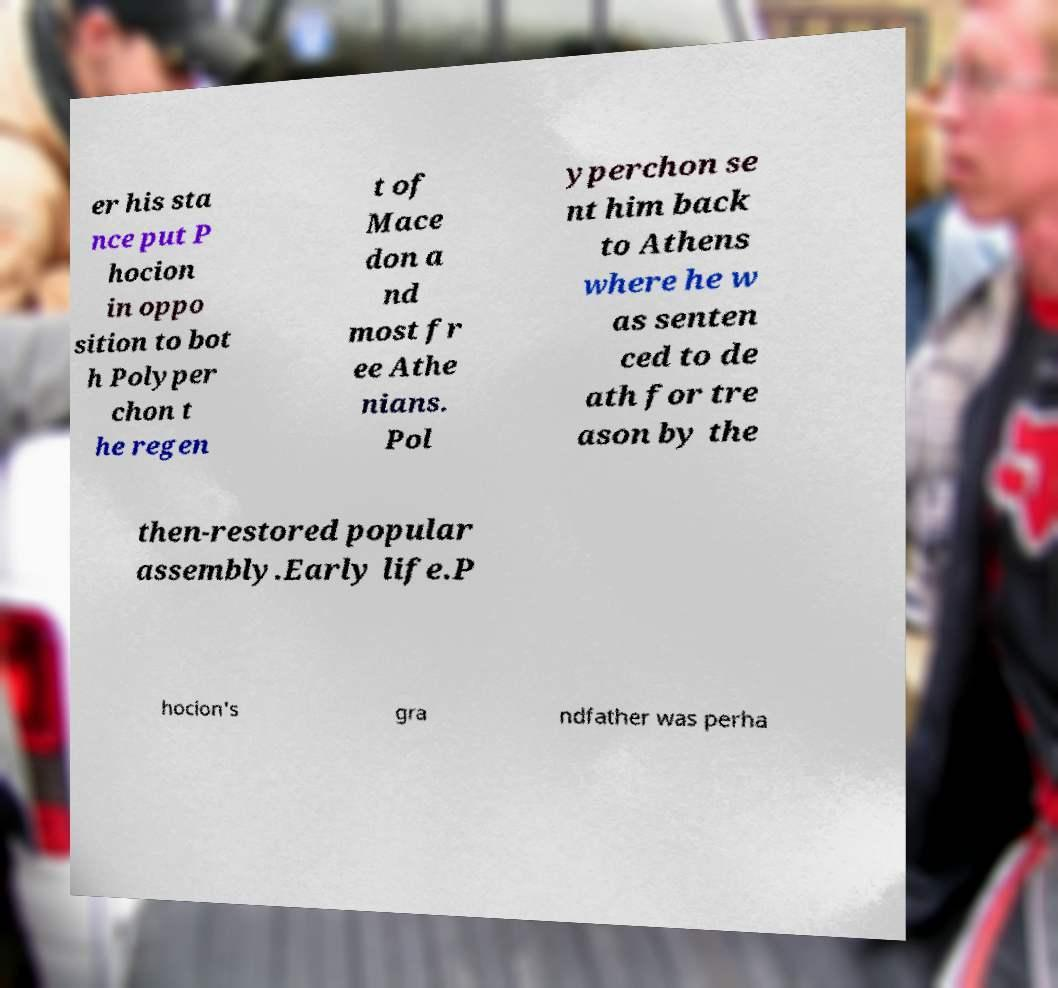Can you accurately transcribe the text from the provided image for me? er his sta nce put P hocion in oppo sition to bot h Polyper chon t he regen t of Mace don a nd most fr ee Athe nians. Pol yperchon se nt him back to Athens where he w as senten ced to de ath for tre ason by the then-restored popular assembly.Early life.P hocion's gra ndfather was perha 